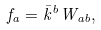Convert formula to latex. <formula><loc_0><loc_0><loc_500><loc_500>f _ { a } = \bar { k } ^ { b } W _ { a b } ,</formula> 